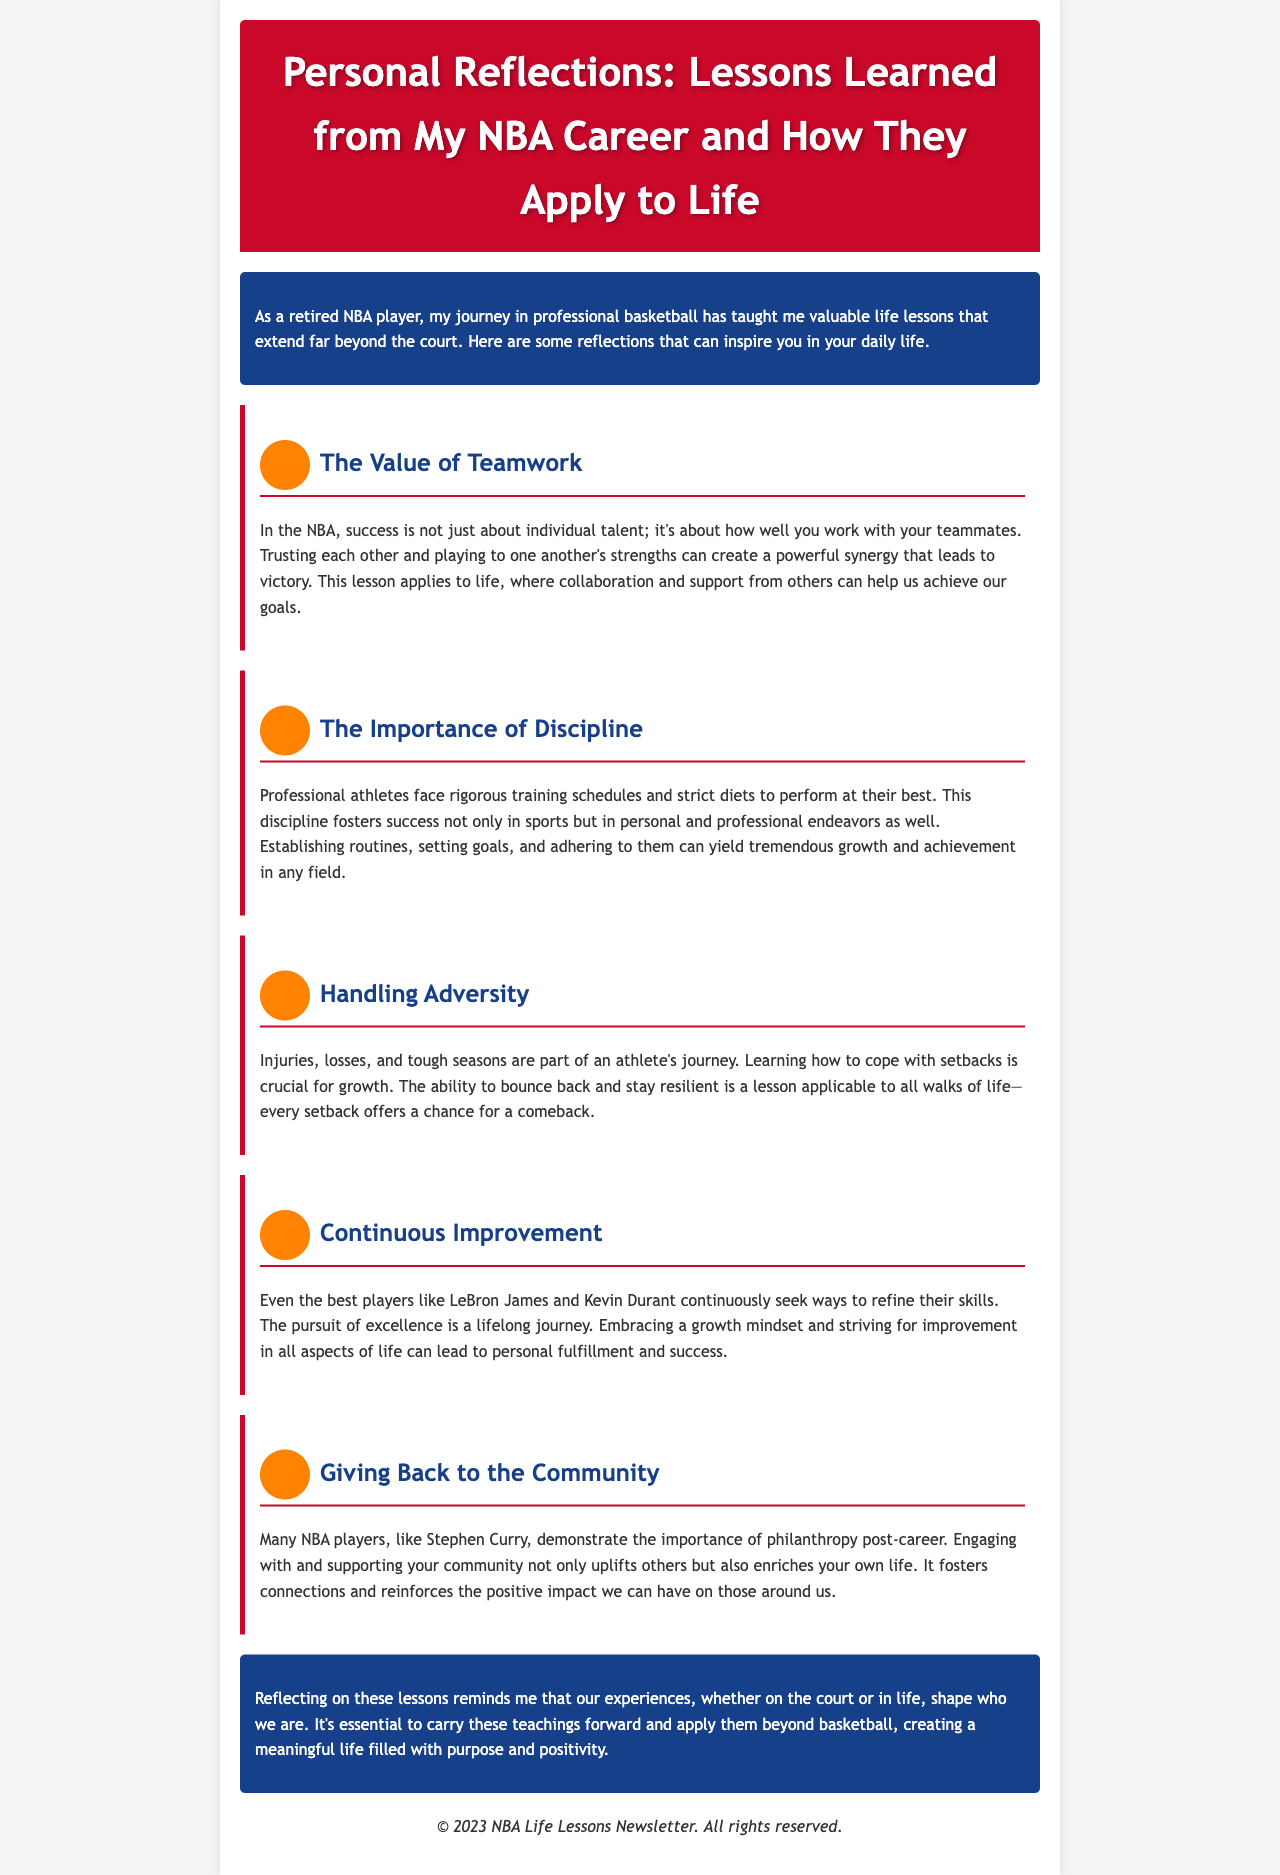What is the title of the newsletter? The title is prominently displayed at the top of the document, which is "Personal Reflections: Lessons Learned from My NBA Career and How They Apply to Life."
Answer: Personal Reflections: Lessons Learned from My NBA Career and How They Apply to Life Who is the audience for this newsletter? The audience can be inferred from the document's content, which speaks to individuals looking for inspiration and life lessons, likely fans or those interested in personal growth.
Answer: Individuals looking for inspiration What is the first lesson mentioned? The first lesson in the document is clearly identified under the heading, which states, "The Value of Teamwork."
Answer: The Value of Teamwork Which player is referenced as an example of continuous improvement? The document cites specific NBA players who exemplify continuous improvement, one being LeBron James.
Answer: LeBron James How does the newsletter describe handling adversity? The description provided highlights that setbacks are crucial for growth and emphasizes resilience.
Answer: Coping with setbacks is crucial for growth What color is used for the header? The header color is specifically mentioned in the document's styling information as "#C9082A."
Answer: #C9082A What is the main theme of the final reflection? The conclusion revisits the importance of experiences shaping identity and carrying forward lessons from basketball into life.
Answer: Carrying forward lessons from basketball into life What does the newsletter promote in terms of community involvement? It emphasizes the significance and positive impact of engaging with and supporting the community, highlighted through player examples.
Answer: Engaging with and supporting the community What is the footer's content about? The footer typically contains copyright information related to the newsletter, stating the year and ownership.
Answer: © 2023 NBA Life Lessons Newsletter. All rights reserved 